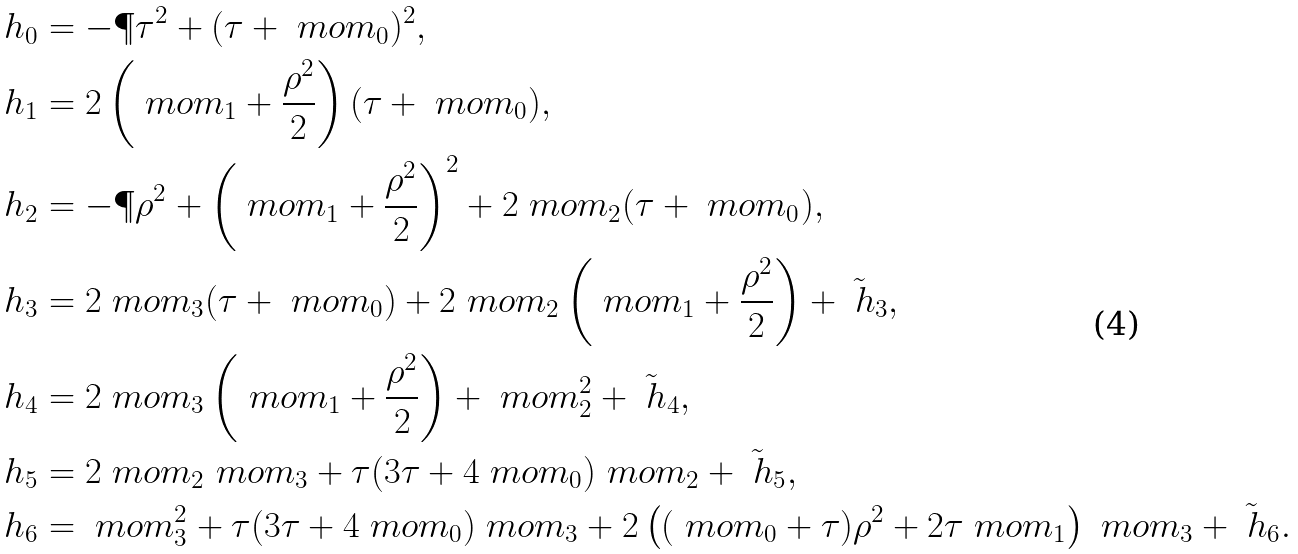<formula> <loc_0><loc_0><loc_500><loc_500>\ h _ { 0 } & = - \P { \tau } ^ { 2 } + ( \tau + \ m o m _ { 0 } ) ^ { 2 } , \\ \ h _ { 1 } & = 2 \left ( \ m o m _ { 1 } + \frac { \rho ^ { 2 } } { 2 } \right ) ( \tau + \ m o m _ { 0 } ) , \\ \ h _ { 2 } & = - \P { \rho } ^ { 2 } + \left ( \ m o m _ { 1 } + \frac { \rho ^ { 2 } } { 2 } \right ) ^ { 2 } + 2 \ m o m _ { 2 } ( \tau + \ m o m _ { 0 } ) , \\ \ h _ { 3 } & = 2 \ m o m _ { 3 } ( \tau + \ m o m _ { 0 } ) + 2 \ m o m _ { 2 } \left ( \ m o m _ { 1 } + \frac { \rho ^ { 2 } } { 2 } \right ) + \tilde { \ h } _ { 3 } , \\ \ h _ { 4 } & = 2 \ m o m _ { 3 } \left ( \ m o m _ { 1 } + \frac { \rho ^ { 2 } } { 2 } \right ) + \ m o m _ { 2 } ^ { 2 } + \tilde { \ h } _ { 4 } , \\ \ h _ { 5 } & = 2 \ m o m _ { 2 } \ m o m _ { 3 } + \tau ( 3 \tau + 4 \ m o m _ { 0 } ) \ m o m _ { 2 } + \tilde { \ h } _ { 5 } , \\ \ h _ { 6 } & = \ m o m _ { 3 } ^ { 2 } + \tau ( 3 \tau + 4 \ m o m _ { 0 } ) \ m o m _ { 3 } + 2 \left ( ( \ m o m _ { 0 } + \tau ) \rho ^ { 2 } + 2 \tau \ m o m _ { 1 } \right ) \ m o m _ { 3 } + \tilde { \ h } _ { 6 } .</formula> 